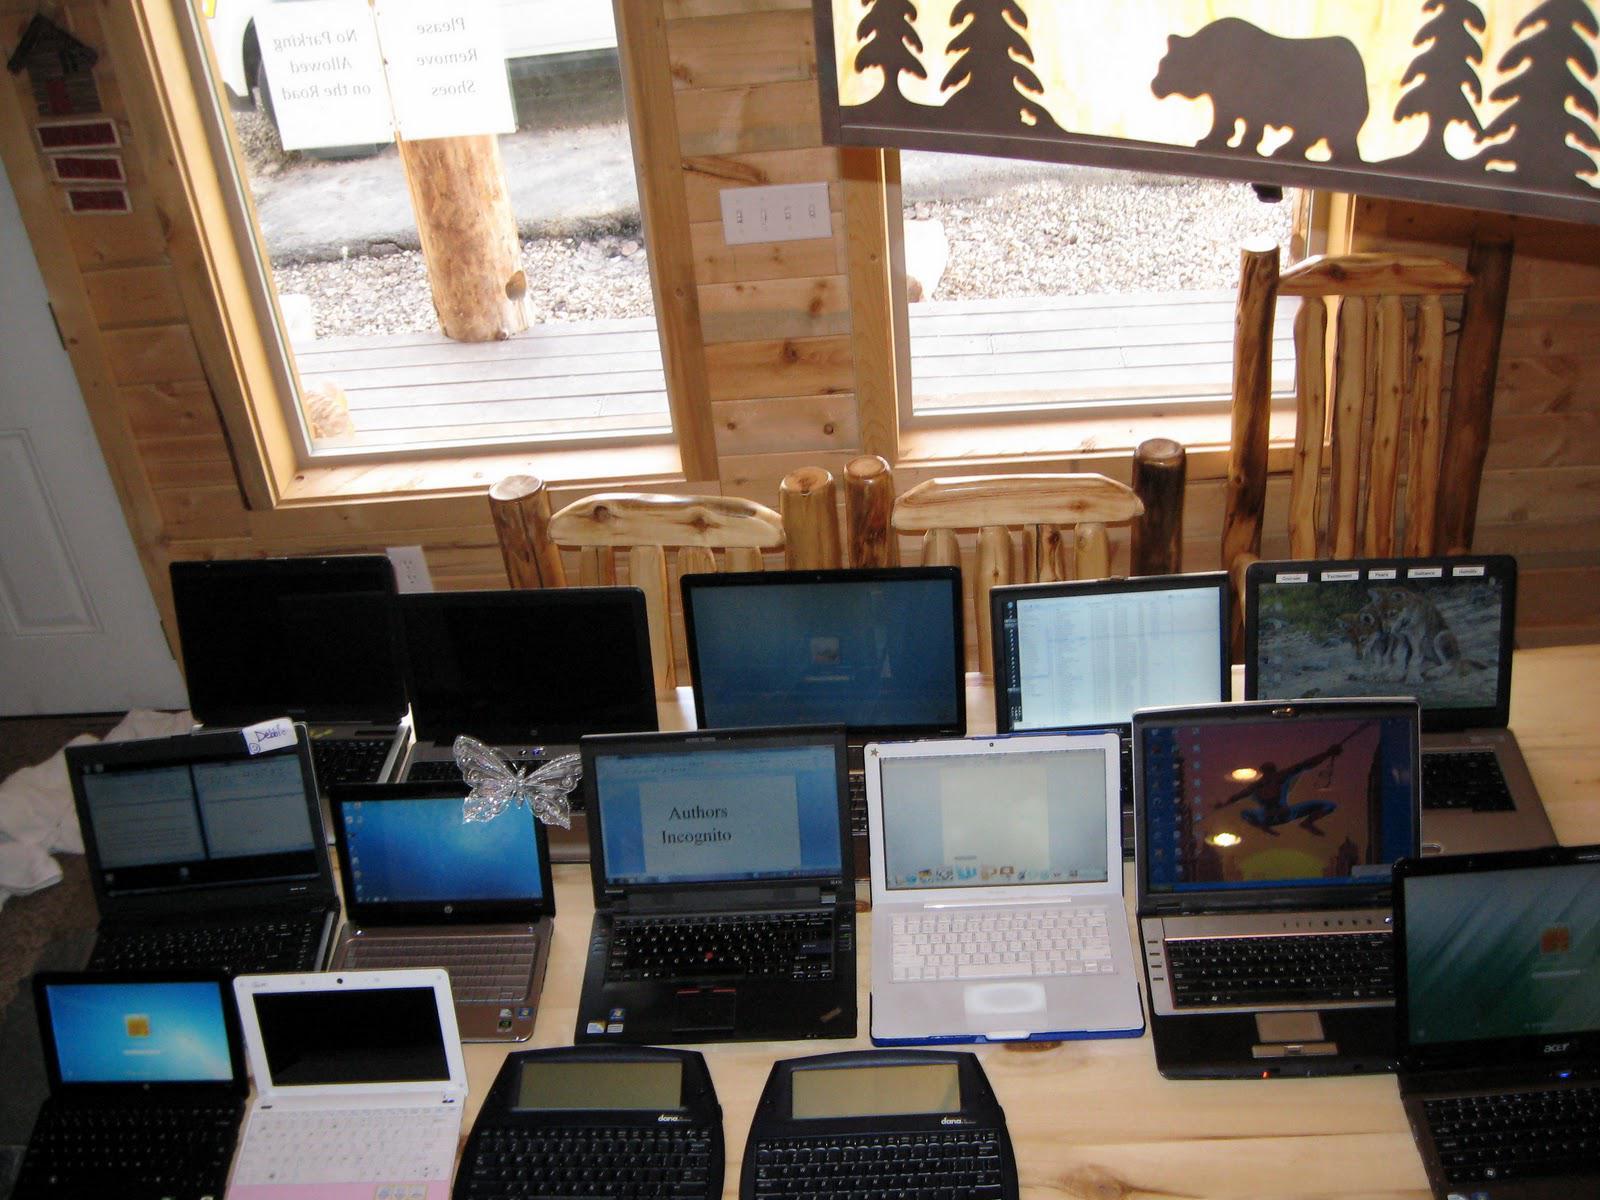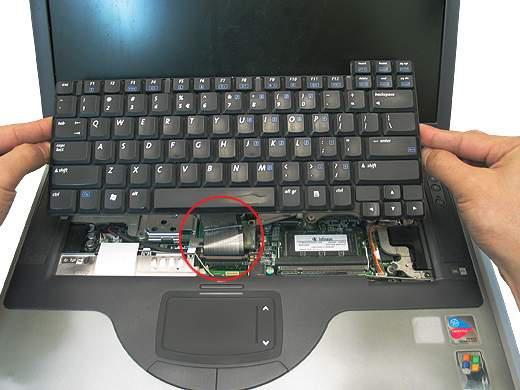The first image is the image on the left, the second image is the image on the right. Evaluate the accuracy of this statement regarding the images: "At least one human hand is near a laptop in the right image.". Is it true? Answer yes or no. Yes. The first image is the image on the left, the second image is the image on the right. Considering the images on both sides, is "An image shows one open laptop with at least one hand visible at a side of the image." valid? Answer yes or no. Yes. 